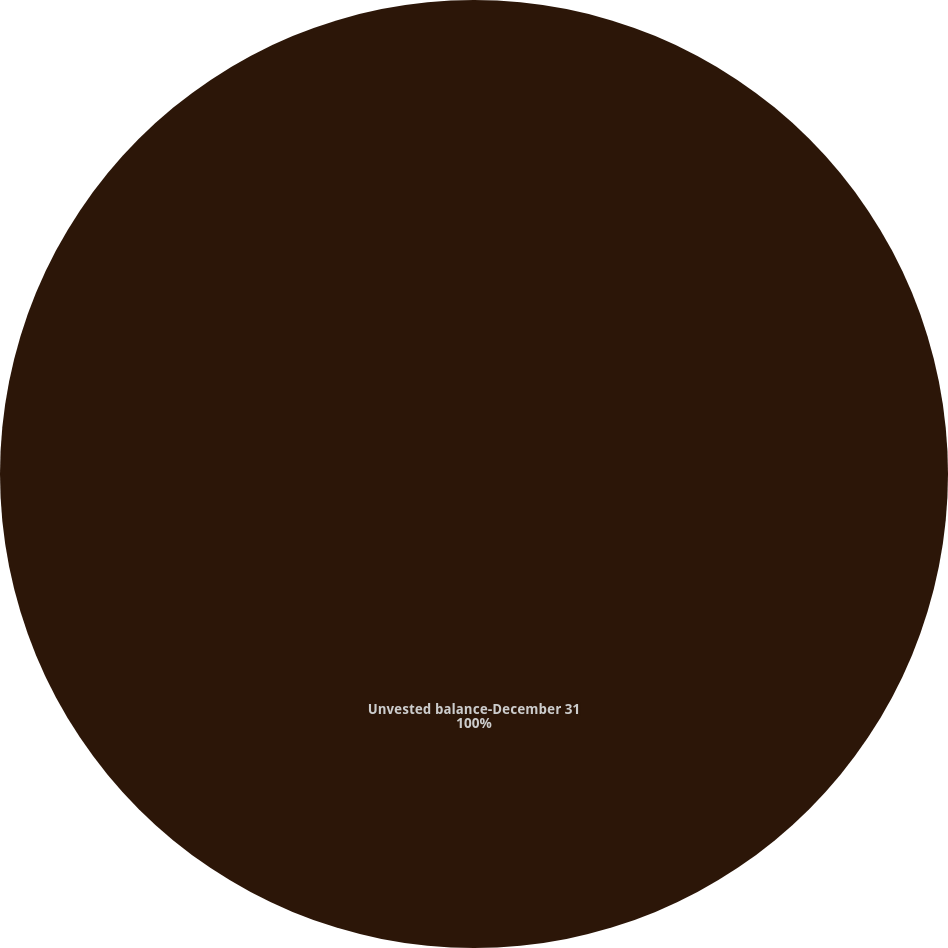Convert chart. <chart><loc_0><loc_0><loc_500><loc_500><pie_chart><fcel>Unvested balance-December 31<nl><fcel>100.0%<nl></chart> 